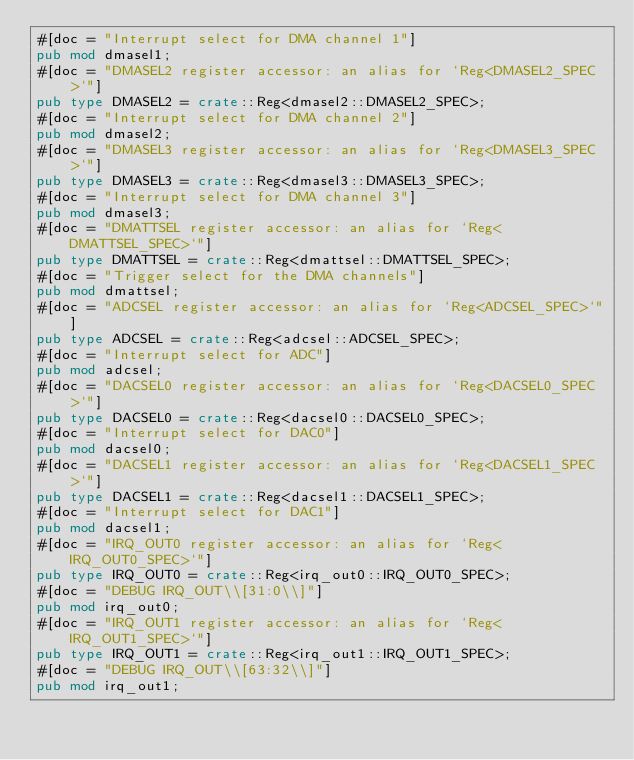Convert code to text. <code><loc_0><loc_0><loc_500><loc_500><_Rust_>#[doc = "Interrupt select for DMA channel 1"]
pub mod dmasel1;
#[doc = "DMASEL2 register accessor: an alias for `Reg<DMASEL2_SPEC>`"]
pub type DMASEL2 = crate::Reg<dmasel2::DMASEL2_SPEC>;
#[doc = "Interrupt select for DMA channel 2"]
pub mod dmasel2;
#[doc = "DMASEL3 register accessor: an alias for `Reg<DMASEL3_SPEC>`"]
pub type DMASEL3 = crate::Reg<dmasel3::DMASEL3_SPEC>;
#[doc = "Interrupt select for DMA channel 3"]
pub mod dmasel3;
#[doc = "DMATTSEL register accessor: an alias for `Reg<DMATTSEL_SPEC>`"]
pub type DMATTSEL = crate::Reg<dmattsel::DMATTSEL_SPEC>;
#[doc = "Trigger select for the DMA channels"]
pub mod dmattsel;
#[doc = "ADCSEL register accessor: an alias for `Reg<ADCSEL_SPEC>`"]
pub type ADCSEL = crate::Reg<adcsel::ADCSEL_SPEC>;
#[doc = "Interrupt select for ADC"]
pub mod adcsel;
#[doc = "DACSEL0 register accessor: an alias for `Reg<DACSEL0_SPEC>`"]
pub type DACSEL0 = crate::Reg<dacsel0::DACSEL0_SPEC>;
#[doc = "Interrupt select for DAC0"]
pub mod dacsel0;
#[doc = "DACSEL1 register accessor: an alias for `Reg<DACSEL1_SPEC>`"]
pub type DACSEL1 = crate::Reg<dacsel1::DACSEL1_SPEC>;
#[doc = "Interrupt select for DAC1"]
pub mod dacsel1;
#[doc = "IRQ_OUT0 register accessor: an alias for `Reg<IRQ_OUT0_SPEC>`"]
pub type IRQ_OUT0 = crate::Reg<irq_out0::IRQ_OUT0_SPEC>;
#[doc = "DEBUG IRQ_OUT\\[31:0\\]"]
pub mod irq_out0;
#[doc = "IRQ_OUT1 register accessor: an alias for `Reg<IRQ_OUT1_SPEC>`"]
pub type IRQ_OUT1 = crate::Reg<irq_out1::IRQ_OUT1_SPEC>;
#[doc = "DEBUG IRQ_OUT\\[63:32\\]"]
pub mod irq_out1;</code> 